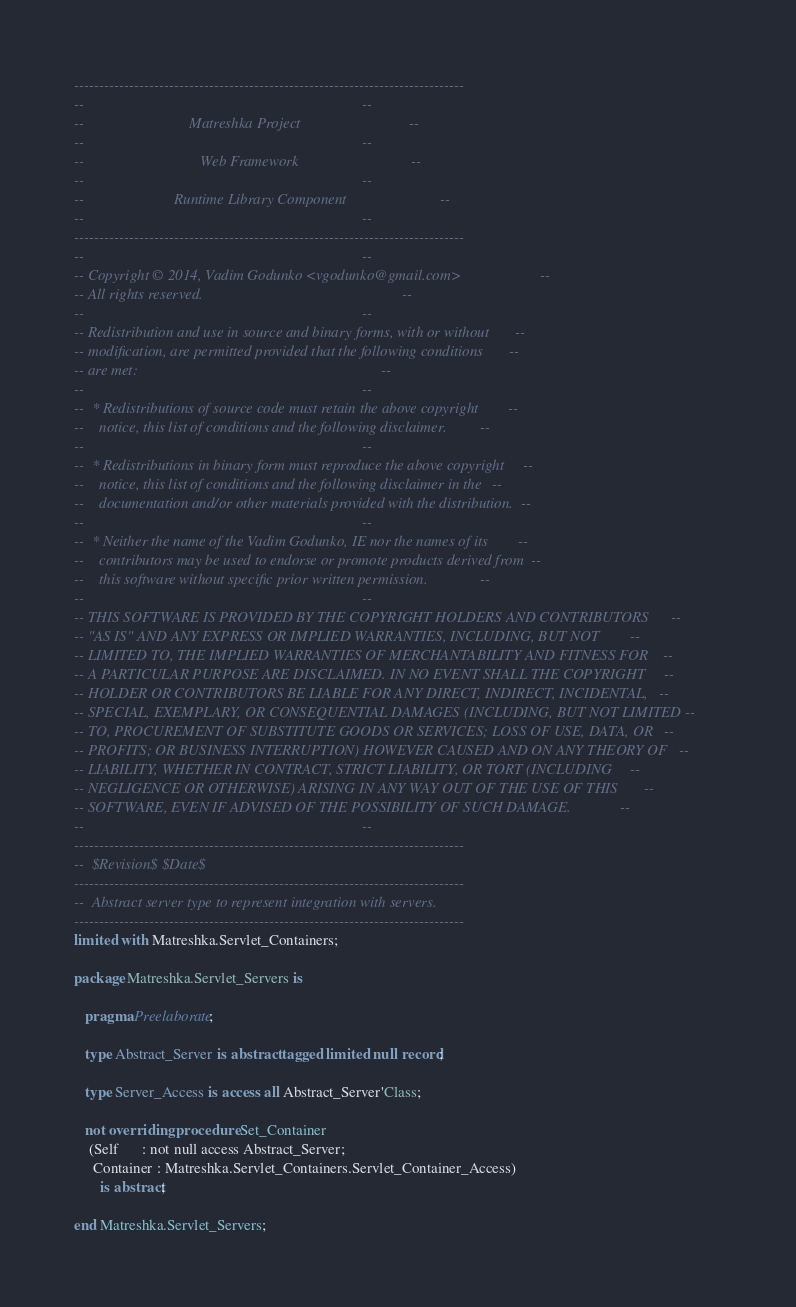Convert code to text. <code><loc_0><loc_0><loc_500><loc_500><_Ada_>------------------------------------------------------------------------------
--                                                                          --
--                            Matreshka Project                             --
--                                                                          --
--                               Web Framework                              --
--                                                                          --
--                        Runtime Library Component                         --
--                                                                          --
------------------------------------------------------------------------------
--                                                                          --
-- Copyright © 2014, Vadim Godunko <vgodunko@gmail.com>                     --
-- All rights reserved.                                                     --
--                                                                          --
-- Redistribution and use in source and binary forms, with or without       --
-- modification, are permitted provided that the following conditions       --
-- are met:                                                                 --
--                                                                          --
--  * Redistributions of source code must retain the above copyright        --
--    notice, this list of conditions and the following disclaimer.         --
--                                                                          --
--  * Redistributions in binary form must reproduce the above copyright     --
--    notice, this list of conditions and the following disclaimer in the   --
--    documentation and/or other materials provided with the distribution.  --
--                                                                          --
--  * Neither the name of the Vadim Godunko, IE nor the names of its        --
--    contributors may be used to endorse or promote products derived from  --
--    this software without specific prior written permission.              --
--                                                                          --
-- THIS SOFTWARE IS PROVIDED BY THE COPYRIGHT HOLDERS AND CONTRIBUTORS      --
-- "AS IS" AND ANY EXPRESS OR IMPLIED WARRANTIES, INCLUDING, BUT NOT        --
-- LIMITED TO, THE IMPLIED WARRANTIES OF MERCHANTABILITY AND FITNESS FOR    --
-- A PARTICULAR PURPOSE ARE DISCLAIMED. IN NO EVENT SHALL THE COPYRIGHT     --
-- HOLDER OR CONTRIBUTORS BE LIABLE FOR ANY DIRECT, INDIRECT, INCIDENTAL,   --
-- SPECIAL, EXEMPLARY, OR CONSEQUENTIAL DAMAGES (INCLUDING, BUT NOT LIMITED --
-- TO, PROCUREMENT OF SUBSTITUTE GOODS OR SERVICES; LOSS OF USE, DATA, OR   --
-- PROFITS; OR BUSINESS INTERRUPTION) HOWEVER CAUSED AND ON ANY THEORY OF   --
-- LIABILITY, WHETHER IN CONTRACT, STRICT LIABILITY, OR TORT (INCLUDING     --
-- NEGLIGENCE OR OTHERWISE) ARISING IN ANY WAY OUT OF THE USE OF THIS       --
-- SOFTWARE, EVEN IF ADVISED OF THE POSSIBILITY OF SUCH DAMAGE.             --
--                                                                          --
------------------------------------------------------------------------------
--  $Revision$ $Date$
------------------------------------------------------------------------------
--  Abstract server type to represent integration with servers.
------------------------------------------------------------------------------
limited with Matreshka.Servlet_Containers;

package Matreshka.Servlet_Servers is

   pragma Preelaborate;

   type Abstract_Server is abstract tagged limited null record;

   type Server_Access is access all Abstract_Server'Class;

   not overriding procedure Set_Container
    (Self      : not null access Abstract_Server;
     Container : Matreshka.Servlet_Containers.Servlet_Container_Access)
       is abstract;

end Matreshka.Servlet_Servers;
</code> 